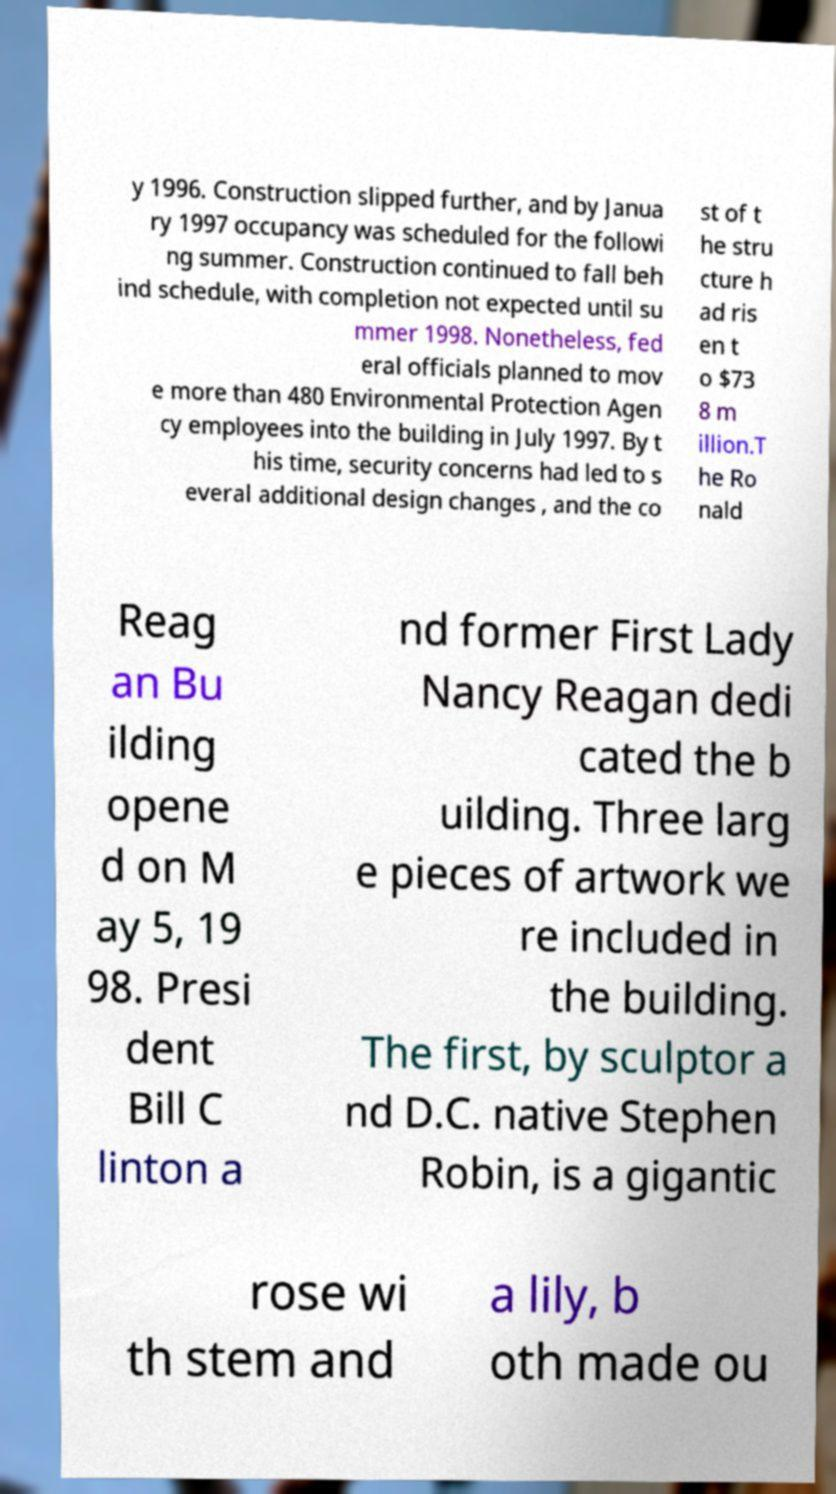Please identify and transcribe the text found in this image. y 1996. Construction slipped further, and by Janua ry 1997 occupancy was scheduled for the followi ng summer. Construction continued to fall beh ind schedule, with completion not expected until su mmer 1998. Nonetheless, fed eral officials planned to mov e more than 480 Environmental Protection Agen cy employees into the building in July 1997. By t his time, security concerns had led to s everal additional design changes , and the co st of t he stru cture h ad ris en t o $73 8 m illion.T he Ro nald Reag an Bu ilding opene d on M ay 5, 19 98. Presi dent Bill C linton a nd former First Lady Nancy Reagan dedi cated the b uilding. Three larg e pieces of artwork we re included in the building. The first, by sculptor a nd D.C. native Stephen Robin, is a gigantic rose wi th stem and a lily, b oth made ou 